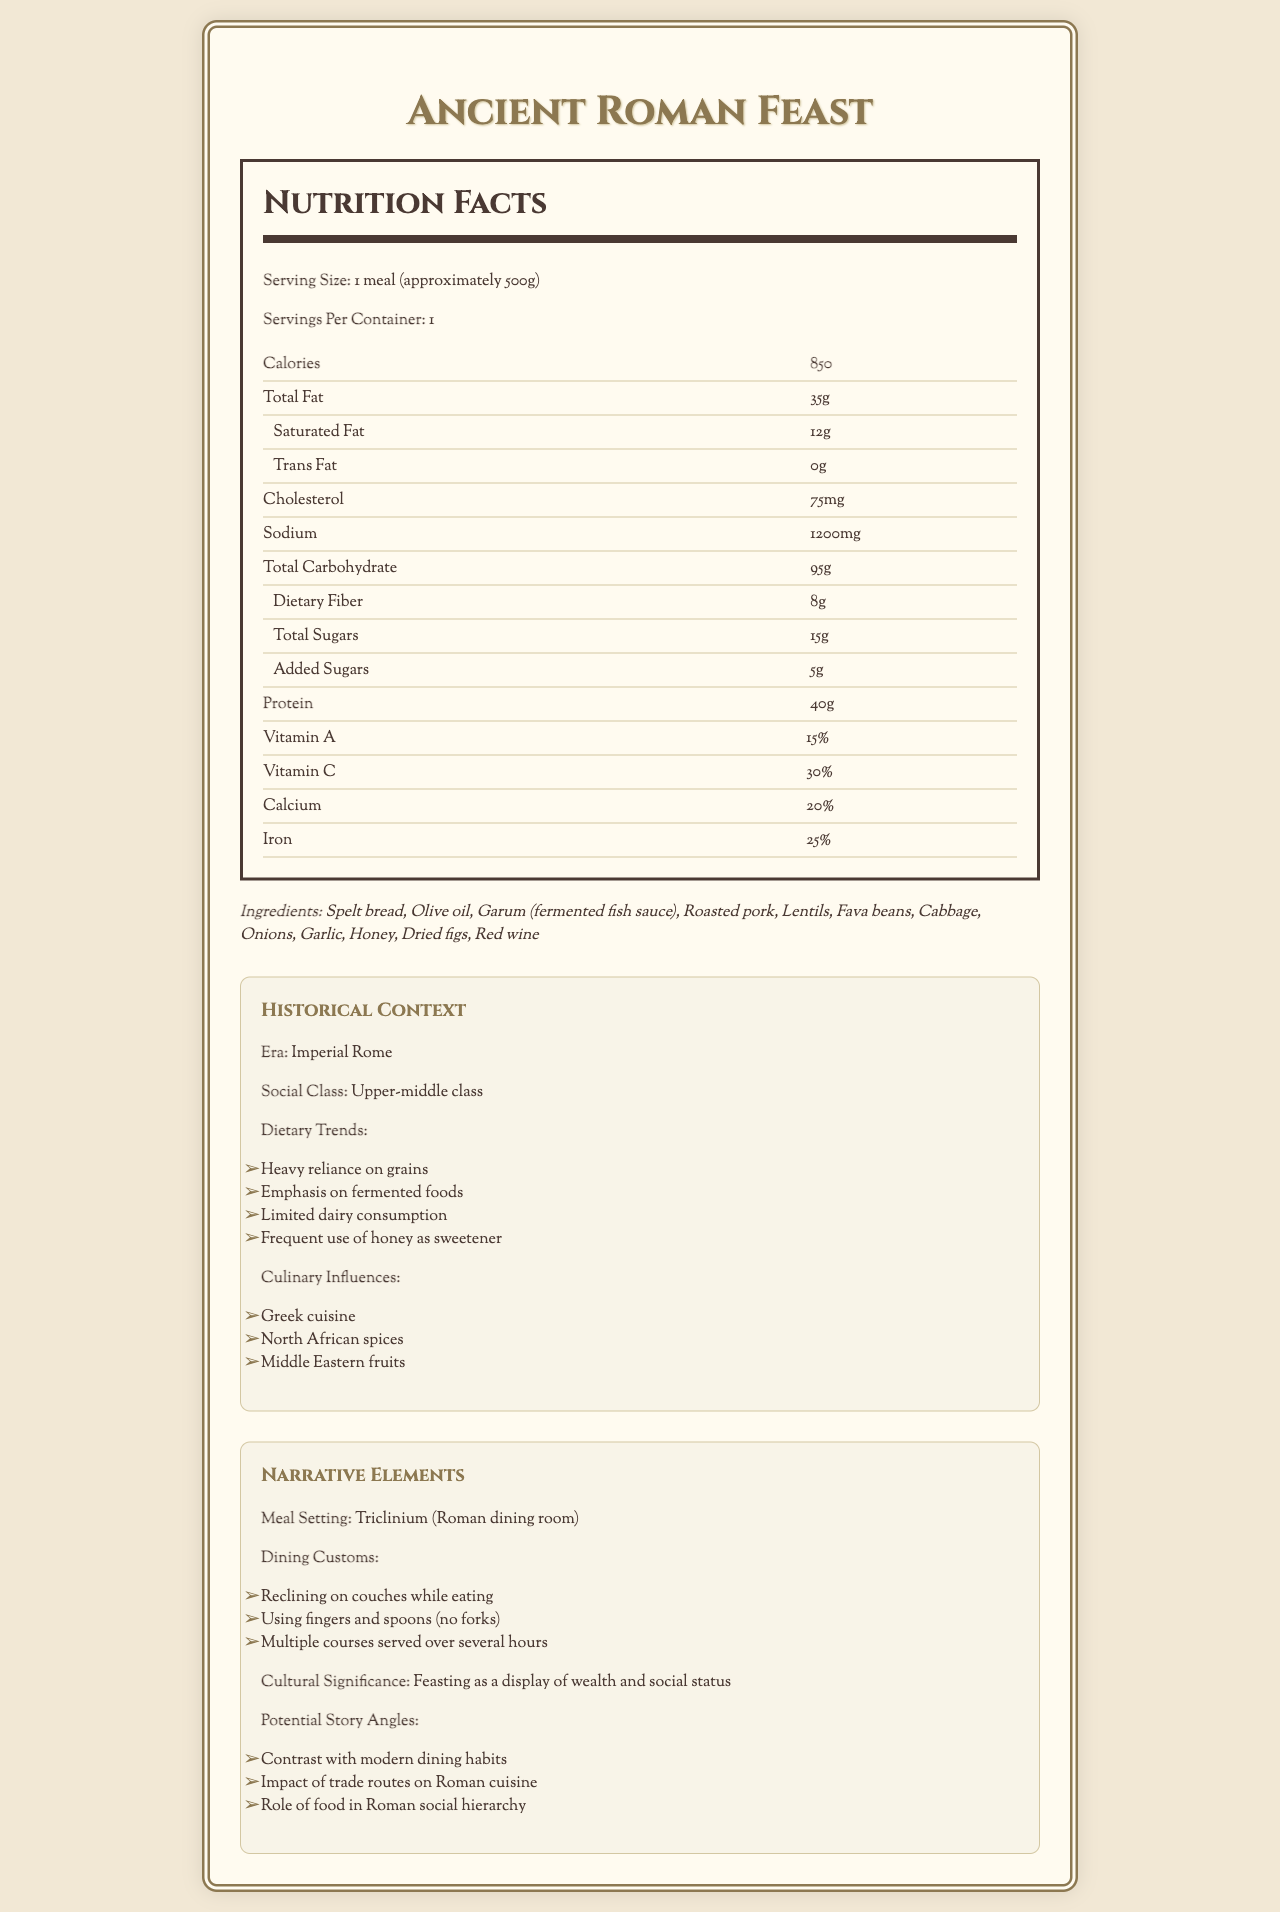How many calories are in the Ancient Roman Feast? The nutrition label in the document lists the calorie content as 850.
Answer: 850 What is the serving size of the meal? The serving size is detailed at the top of the nutrition label section.
Answer: 1 meal (approximately 500g) List three ingredients used in the Ancient Roman Feast. The ingredients section includes "Spelt bread," "Olive oil," and "Garum (fermented fish sauce)."
Answer: Spelt bread, Olive oil, Garum (fermented fish sauce) Which vitamin is present at the highest percentage in the meal? The vitamins and minerals section indicates Vitamin C is present at 30%, which is the highest among the listed vitamins and minerals.
Answer: Vitamin C Which dietary trend is mentioned in the historical context? One of the listed dietary trends in the historical context section is "Heavy reliance on grains."
Answer: Heavy reliance on grains Which social class likely consumed this meal? A. Lower class B. Middle class C. Upper-middle class D. Nobility The historical context section mentions that the meal is typical of the upper-middle class.
Answer: C What role did food play in Roman social hierarchy? A. As a necessity B. As a religious offering C. As a display of wealth and social status D. As a form of punishment The cultural significance section states "Feasting as a display of wealth and social status."
Answer: C Is red wine listed as an ingredient in this meal? The ingredients section includes "Red wine" among the meal components.
Answer: Yes What is the main setting for this meal? The narrative elements section specifies that the meal setting is a "Triclinium."
Answer: Triclinium (Roman dining room) Is the consumption of dairy a major trend in this diet? The dietary trends section explicitly mentions "Limited dairy consumption."
Answer: No Summarize the nutritional profile and cultural context of the Ancient Roman Feast. The document outlines the nutritional content of the meal: 850 calories, significant amounts of fat (35g), carbohydrate (95g), protein (40g), and essential vitamins and minerals. The ingredients reflect typical foods of the time, influenced by Greek, North African, and Middle Eastern cuisines. The historical context places the meal in the upper-middle class of Imperial Rome, showcasing social and culinary traditions.
Answer: The Ancient Roman Feast is a high-calorie meal (850 calories) with a balanced composition of fats, carbohydrates, and proteins. It's rich in vitamins A and C, calcium, and iron. The meal features ingredients like spelt bread, olive oil, and roasted pork, common among the upper-middle class during Imperial Rome. Dining customs involved reclining on couches and eating with fingers and spoons. The feast functions as a display of wealth and social status. How many grams of added sugars are in the meal? The nutrition label indicates there are 5 grams of added sugars.
Answer: 5 What is the cholesterol content of the Ancient Roman Feast? The nutrition label lists the cholesterol content as 75 mg.
Answer: 75 mg Which ingredients are used for sweetness in this meal? The ingredients section lists both "Honey" and "Dried figs," which are used for sweetness.
Answer: Honey, Dried figs Identify one potential story angle mentioned in the document. The narrative elements section lists "Impact of trade routes on Roman cuisine" as one of the potential story angles.
Answer: Impact of trade routes on Roman cuisine Which of the following is a major carbohydrate source in the meal? A. Olive oil B. Roasted pork C. Spelt bread D. Garlic Spelt bread is a major carbohydrate source, as listed in the ingredients section.
Answer: C What percentage of calcium is provided by the meal? The vitamins and minerals section shows that the meal provides 20% of the daily recommended calcium intake.
Answer: 20% What is the primary method of dining described? The dining customs section mentions "Reclining on couches while eating" as the primary method of dining.
Answer: Reclining on couches while eating What role does garum play in the meal? The document mentions garum as an ingredient but does not specify its role beyond that.
Answer: Not enough information What are the total grams of dietary fiber in the meal? According to the nutrition label, the total dietary fiber is 8 grams.
Answer: 8g 